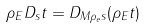<formula> <loc_0><loc_0><loc_500><loc_500>\rho _ { E } D _ { s } t = D _ { M \rho _ { e } s } ( \rho _ { E } t )</formula> 